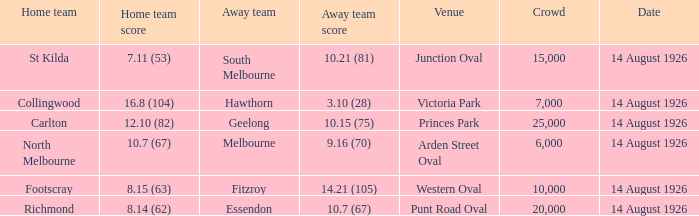What is the sum of all the crowds that watched North Melbourne at home? 6000.0. 